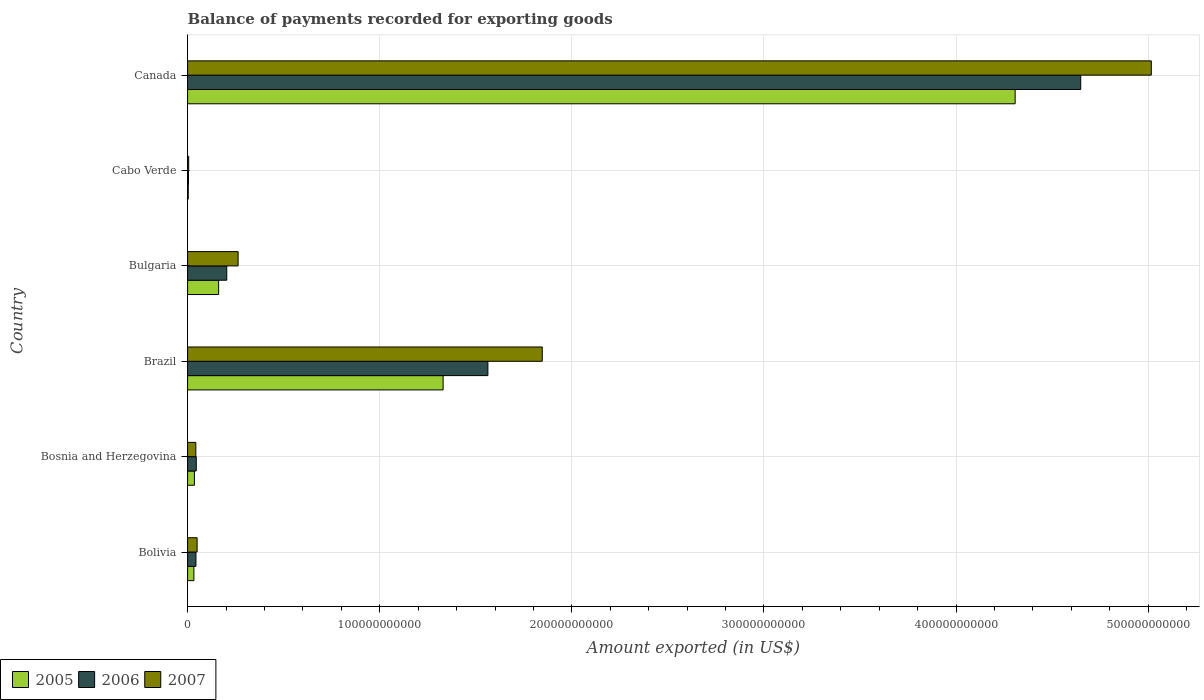How many different coloured bars are there?
Offer a terse response. 3. Are the number of bars on each tick of the Y-axis equal?
Make the answer very short. Yes. What is the label of the 5th group of bars from the top?
Provide a short and direct response. Bosnia and Herzegovina. In how many cases, is the number of bars for a given country not equal to the number of legend labels?
Give a very brief answer. 0. What is the amount exported in 2007 in Cabo Verde?
Your answer should be compact. 5.66e+08. Across all countries, what is the maximum amount exported in 2006?
Provide a succinct answer. 4.65e+11. Across all countries, what is the minimum amount exported in 2007?
Offer a terse response. 5.66e+08. In which country was the amount exported in 2005 maximum?
Your answer should be very brief. Canada. In which country was the amount exported in 2006 minimum?
Offer a very short reply. Cabo Verde. What is the total amount exported in 2006 in the graph?
Your answer should be very brief. 6.51e+11. What is the difference between the amount exported in 2005 in Bosnia and Herzegovina and that in Canada?
Provide a short and direct response. -4.27e+11. What is the difference between the amount exported in 2005 in Bolivia and the amount exported in 2007 in Bosnia and Herzegovina?
Your response must be concise. -1.01e+09. What is the average amount exported in 2007 per country?
Make the answer very short. 1.20e+11. What is the difference between the amount exported in 2007 and amount exported in 2005 in Cabo Verde?
Keep it short and to the point. 2.12e+08. In how many countries, is the amount exported in 2007 greater than 440000000000 US$?
Your answer should be compact. 1. What is the ratio of the amount exported in 2005 in Bosnia and Herzegovina to that in Bulgaria?
Provide a short and direct response. 0.22. What is the difference between the highest and the second highest amount exported in 2007?
Your answer should be very brief. 3.17e+11. What is the difference between the highest and the lowest amount exported in 2006?
Offer a terse response. 4.64e+11. How many bars are there?
Give a very brief answer. 18. Are all the bars in the graph horizontal?
Offer a very short reply. Yes. What is the difference between two consecutive major ticks on the X-axis?
Your answer should be very brief. 1.00e+11. Are the values on the major ticks of X-axis written in scientific E-notation?
Give a very brief answer. No. Does the graph contain any zero values?
Keep it short and to the point. No. Does the graph contain grids?
Ensure brevity in your answer.  Yes. Where does the legend appear in the graph?
Your response must be concise. Bottom left. What is the title of the graph?
Make the answer very short. Balance of payments recorded for exporting goods. Does "1981" appear as one of the legend labels in the graph?
Your answer should be compact. No. What is the label or title of the X-axis?
Keep it short and to the point. Amount exported (in US$). What is the Amount exported (in US$) in 2005 in Bolivia?
Your response must be concise. 3.28e+09. What is the Amount exported (in US$) in 2006 in Bolivia?
Offer a very short reply. 4.35e+09. What is the Amount exported (in US$) in 2007 in Bolivia?
Your response must be concise. 4.95e+09. What is the Amount exported (in US$) of 2005 in Bosnia and Herzegovina?
Provide a short and direct response. 3.54e+09. What is the Amount exported (in US$) in 2006 in Bosnia and Herzegovina?
Your answer should be very brief. 4.52e+09. What is the Amount exported (in US$) of 2007 in Bosnia and Herzegovina?
Give a very brief answer. 4.29e+09. What is the Amount exported (in US$) of 2005 in Brazil?
Provide a succinct answer. 1.33e+11. What is the Amount exported (in US$) of 2006 in Brazil?
Offer a very short reply. 1.56e+11. What is the Amount exported (in US$) in 2007 in Brazil?
Keep it short and to the point. 1.85e+11. What is the Amount exported (in US$) of 2005 in Bulgaria?
Your answer should be very brief. 1.62e+1. What is the Amount exported (in US$) of 2006 in Bulgaria?
Your response must be concise. 2.04e+1. What is the Amount exported (in US$) in 2007 in Bulgaria?
Your answer should be very brief. 2.63e+1. What is the Amount exported (in US$) in 2005 in Cabo Verde?
Keep it short and to the point. 3.54e+08. What is the Amount exported (in US$) of 2006 in Cabo Verde?
Make the answer very short. 4.72e+08. What is the Amount exported (in US$) in 2007 in Cabo Verde?
Provide a short and direct response. 5.66e+08. What is the Amount exported (in US$) of 2005 in Canada?
Your answer should be compact. 4.31e+11. What is the Amount exported (in US$) of 2006 in Canada?
Keep it short and to the point. 4.65e+11. What is the Amount exported (in US$) in 2007 in Canada?
Offer a terse response. 5.02e+11. Across all countries, what is the maximum Amount exported (in US$) in 2005?
Keep it short and to the point. 4.31e+11. Across all countries, what is the maximum Amount exported (in US$) in 2006?
Your answer should be very brief. 4.65e+11. Across all countries, what is the maximum Amount exported (in US$) of 2007?
Your answer should be compact. 5.02e+11. Across all countries, what is the minimum Amount exported (in US$) in 2005?
Your response must be concise. 3.54e+08. Across all countries, what is the minimum Amount exported (in US$) of 2006?
Give a very brief answer. 4.72e+08. Across all countries, what is the minimum Amount exported (in US$) of 2007?
Your response must be concise. 5.66e+08. What is the total Amount exported (in US$) of 2005 in the graph?
Offer a very short reply. 5.87e+11. What is the total Amount exported (in US$) of 2006 in the graph?
Provide a succinct answer. 6.51e+11. What is the total Amount exported (in US$) in 2007 in the graph?
Give a very brief answer. 7.22e+11. What is the difference between the Amount exported (in US$) in 2005 in Bolivia and that in Bosnia and Herzegovina?
Your answer should be compact. -2.65e+08. What is the difference between the Amount exported (in US$) in 2006 in Bolivia and that in Bosnia and Herzegovina?
Your response must be concise. -1.72e+08. What is the difference between the Amount exported (in US$) in 2007 in Bolivia and that in Bosnia and Herzegovina?
Your answer should be compact. 6.67e+08. What is the difference between the Amount exported (in US$) in 2005 in Bolivia and that in Brazil?
Provide a succinct answer. -1.30e+11. What is the difference between the Amount exported (in US$) of 2006 in Bolivia and that in Brazil?
Your answer should be compact. -1.52e+11. What is the difference between the Amount exported (in US$) of 2007 in Bolivia and that in Brazil?
Give a very brief answer. -1.80e+11. What is the difference between the Amount exported (in US$) in 2005 in Bolivia and that in Bulgaria?
Offer a terse response. -1.29e+1. What is the difference between the Amount exported (in US$) in 2006 in Bolivia and that in Bulgaria?
Offer a terse response. -1.60e+1. What is the difference between the Amount exported (in US$) of 2007 in Bolivia and that in Bulgaria?
Your answer should be compact. -2.13e+1. What is the difference between the Amount exported (in US$) of 2005 in Bolivia and that in Cabo Verde?
Your response must be concise. 2.93e+09. What is the difference between the Amount exported (in US$) in 2006 in Bolivia and that in Cabo Verde?
Give a very brief answer. 3.88e+09. What is the difference between the Amount exported (in US$) of 2007 in Bolivia and that in Cabo Verde?
Offer a terse response. 4.39e+09. What is the difference between the Amount exported (in US$) in 2005 in Bolivia and that in Canada?
Keep it short and to the point. -4.27e+11. What is the difference between the Amount exported (in US$) in 2006 in Bolivia and that in Canada?
Give a very brief answer. -4.61e+11. What is the difference between the Amount exported (in US$) of 2007 in Bolivia and that in Canada?
Offer a very short reply. -4.97e+11. What is the difference between the Amount exported (in US$) of 2005 in Bosnia and Herzegovina and that in Brazil?
Offer a very short reply. -1.29e+11. What is the difference between the Amount exported (in US$) of 2006 in Bosnia and Herzegovina and that in Brazil?
Your response must be concise. -1.52e+11. What is the difference between the Amount exported (in US$) in 2007 in Bosnia and Herzegovina and that in Brazil?
Give a very brief answer. -1.80e+11. What is the difference between the Amount exported (in US$) in 2005 in Bosnia and Herzegovina and that in Bulgaria?
Offer a very short reply. -1.26e+1. What is the difference between the Amount exported (in US$) of 2006 in Bosnia and Herzegovina and that in Bulgaria?
Give a very brief answer. -1.59e+1. What is the difference between the Amount exported (in US$) in 2007 in Bosnia and Herzegovina and that in Bulgaria?
Your response must be concise. -2.20e+1. What is the difference between the Amount exported (in US$) of 2005 in Bosnia and Herzegovina and that in Cabo Verde?
Your answer should be compact. 3.19e+09. What is the difference between the Amount exported (in US$) in 2006 in Bosnia and Herzegovina and that in Cabo Verde?
Provide a short and direct response. 4.05e+09. What is the difference between the Amount exported (in US$) of 2007 in Bosnia and Herzegovina and that in Cabo Verde?
Your answer should be compact. 3.72e+09. What is the difference between the Amount exported (in US$) in 2005 in Bosnia and Herzegovina and that in Canada?
Offer a very short reply. -4.27e+11. What is the difference between the Amount exported (in US$) in 2006 in Bosnia and Herzegovina and that in Canada?
Provide a short and direct response. -4.60e+11. What is the difference between the Amount exported (in US$) of 2007 in Bosnia and Herzegovina and that in Canada?
Your answer should be compact. -4.97e+11. What is the difference between the Amount exported (in US$) in 2005 in Brazil and that in Bulgaria?
Give a very brief answer. 1.17e+11. What is the difference between the Amount exported (in US$) in 2006 in Brazil and that in Bulgaria?
Your answer should be compact. 1.36e+11. What is the difference between the Amount exported (in US$) of 2007 in Brazil and that in Bulgaria?
Give a very brief answer. 1.58e+11. What is the difference between the Amount exported (in US$) of 2005 in Brazil and that in Cabo Verde?
Offer a terse response. 1.33e+11. What is the difference between the Amount exported (in US$) of 2006 in Brazil and that in Cabo Verde?
Your answer should be very brief. 1.56e+11. What is the difference between the Amount exported (in US$) of 2007 in Brazil and that in Cabo Verde?
Offer a terse response. 1.84e+11. What is the difference between the Amount exported (in US$) of 2005 in Brazil and that in Canada?
Your answer should be compact. -2.98e+11. What is the difference between the Amount exported (in US$) of 2006 in Brazil and that in Canada?
Provide a succinct answer. -3.09e+11. What is the difference between the Amount exported (in US$) in 2007 in Brazil and that in Canada?
Provide a succinct answer. -3.17e+11. What is the difference between the Amount exported (in US$) of 2005 in Bulgaria and that in Cabo Verde?
Keep it short and to the point. 1.58e+1. What is the difference between the Amount exported (in US$) of 2006 in Bulgaria and that in Cabo Verde?
Ensure brevity in your answer.  1.99e+1. What is the difference between the Amount exported (in US$) of 2007 in Bulgaria and that in Cabo Verde?
Give a very brief answer. 2.57e+1. What is the difference between the Amount exported (in US$) of 2005 in Bulgaria and that in Canada?
Your response must be concise. -4.15e+11. What is the difference between the Amount exported (in US$) of 2006 in Bulgaria and that in Canada?
Provide a succinct answer. -4.44e+11. What is the difference between the Amount exported (in US$) in 2007 in Bulgaria and that in Canada?
Give a very brief answer. -4.75e+11. What is the difference between the Amount exported (in US$) in 2005 in Cabo Verde and that in Canada?
Offer a very short reply. -4.30e+11. What is the difference between the Amount exported (in US$) in 2006 in Cabo Verde and that in Canada?
Make the answer very short. -4.64e+11. What is the difference between the Amount exported (in US$) of 2007 in Cabo Verde and that in Canada?
Offer a very short reply. -5.01e+11. What is the difference between the Amount exported (in US$) of 2005 in Bolivia and the Amount exported (in US$) of 2006 in Bosnia and Herzegovina?
Your response must be concise. -1.24e+09. What is the difference between the Amount exported (in US$) in 2005 in Bolivia and the Amount exported (in US$) in 2007 in Bosnia and Herzegovina?
Ensure brevity in your answer.  -1.01e+09. What is the difference between the Amount exported (in US$) in 2006 in Bolivia and the Amount exported (in US$) in 2007 in Bosnia and Herzegovina?
Provide a short and direct response. 6.18e+07. What is the difference between the Amount exported (in US$) in 2005 in Bolivia and the Amount exported (in US$) in 2006 in Brazil?
Your answer should be compact. -1.53e+11. What is the difference between the Amount exported (in US$) in 2005 in Bolivia and the Amount exported (in US$) in 2007 in Brazil?
Give a very brief answer. -1.81e+11. What is the difference between the Amount exported (in US$) of 2006 in Bolivia and the Amount exported (in US$) of 2007 in Brazil?
Provide a short and direct response. -1.80e+11. What is the difference between the Amount exported (in US$) in 2005 in Bolivia and the Amount exported (in US$) in 2006 in Bulgaria?
Offer a very short reply. -1.71e+1. What is the difference between the Amount exported (in US$) in 2005 in Bolivia and the Amount exported (in US$) in 2007 in Bulgaria?
Ensure brevity in your answer.  -2.30e+1. What is the difference between the Amount exported (in US$) of 2006 in Bolivia and the Amount exported (in US$) of 2007 in Bulgaria?
Your answer should be very brief. -2.19e+1. What is the difference between the Amount exported (in US$) in 2005 in Bolivia and the Amount exported (in US$) in 2006 in Cabo Verde?
Offer a very short reply. 2.81e+09. What is the difference between the Amount exported (in US$) in 2005 in Bolivia and the Amount exported (in US$) in 2007 in Cabo Verde?
Offer a very short reply. 2.71e+09. What is the difference between the Amount exported (in US$) of 2006 in Bolivia and the Amount exported (in US$) of 2007 in Cabo Verde?
Provide a succinct answer. 3.78e+09. What is the difference between the Amount exported (in US$) in 2005 in Bolivia and the Amount exported (in US$) in 2006 in Canada?
Provide a succinct answer. -4.62e+11. What is the difference between the Amount exported (in US$) of 2005 in Bolivia and the Amount exported (in US$) of 2007 in Canada?
Provide a succinct answer. -4.98e+11. What is the difference between the Amount exported (in US$) of 2006 in Bolivia and the Amount exported (in US$) of 2007 in Canada?
Your answer should be very brief. -4.97e+11. What is the difference between the Amount exported (in US$) of 2005 in Bosnia and Herzegovina and the Amount exported (in US$) of 2006 in Brazil?
Give a very brief answer. -1.53e+11. What is the difference between the Amount exported (in US$) of 2005 in Bosnia and Herzegovina and the Amount exported (in US$) of 2007 in Brazil?
Keep it short and to the point. -1.81e+11. What is the difference between the Amount exported (in US$) of 2006 in Bosnia and Herzegovina and the Amount exported (in US$) of 2007 in Brazil?
Offer a terse response. -1.80e+11. What is the difference between the Amount exported (in US$) of 2005 in Bosnia and Herzegovina and the Amount exported (in US$) of 2006 in Bulgaria?
Keep it short and to the point. -1.68e+1. What is the difference between the Amount exported (in US$) of 2005 in Bosnia and Herzegovina and the Amount exported (in US$) of 2007 in Bulgaria?
Ensure brevity in your answer.  -2.28e+1. What is the difference between the Amount exported (in US$) in 2006 in Bosnia and Herzegovina and the Amount exported (in US$) in 2007 in Bulgaria?
Keep it short and to the point. -2.18e+1. What is the difference between the Amount exported (in US$) in 2005 in Bosnia and Herzegovina and the Amount exported (in US$) in 2006 in Cabo Verde?
Your response must be concise. 3.07e+09. What is the difference between the Amount exported (in US$) of 2005 in Bosnia and Herzegovina and the Amount exported (in US$) of 2007 in Cabo Verde?
Offer a terse response. 2.98e+09. What is the difference between the Amount exported (in US$) of 2006 in Bosnia and Herzegovina and the Amount exported (in US$) of 2007 in Cabo Verde?
Offer a terse response. 3.96e+09. What is the difference between the Amount exported (in US$) in 2005 in Bosnia and Herzegovina and the Amount exported (in US$) in 2006 in Canada?
Your response must be concise. -4.61e+11. What is the difference between the Amount exported (in US$) in 2005 in Bosnia and Herzegovina and the Amount exported (in US$) in 2007 in Canada?
Your response must be concise. -4.98e+11. What is the difference between the Amount exported (in US$) of 2006 in Bosnia and Herzegovina and the Amount exported (in US$) of 2007 in Canada?
Provide a succinct answer. -4.97e+11. What is the difference between the Amount exported (in US$) in 2005 in Brazil and the Amount exported (in US$) in 2006 in Bulgaria?
Provide a succinct answer. 1.13e+11. What is the difference between the Amount exported (in US$) of 2005 in Brazil and the Amount exported (in US$) of 2007 in Bulgaria?
Provide a succinct answer. 1.07e+11. What is the difference between the Amount exported (in US$) in 2006 in Brazil and the Amount exported (in US$) in 2007 in Bulgaria?
Ensure brevity in your answer.  1.30e+11. What is the difference between the Amount exported (in US$) of 2005 in Brazil and the Amount exported (in US$) of 2006 in Cabo Verde?
Offer a very short reply. 1.33e+11. What is the difference between the Amount exported (in US$) in 2005 in Brazil and the Amount exported (in US$) in 2007 in Cabo Verde?
Your answer should be compact. 1.32e+11. What is the difference between the Amount exported (in US$) in 2006 in Brazil and the Amount exported (in US$) in 2007 in Cabo Verde?
Your answer should be very brief. 1.56e+11. What is the difference between the Amount exported (in US$) of 2005 in Brazil and the Amount exported (in US$) of 2006 in Canada?
Provide a succinct answer. -3.32e+11. What is the difference between the Amount exported (in US$) in 2005 in Brazil and the Amount exported (in US$) in 2007 in Canada?
Your response must be concise. -3.69e+11. What is the difference between the Amount exported (in US$) of 2006 in Brazil and the Amount exported (in US$) of 2007 in Canada?
Make the answer very short. -3.45e+11. What is the difference between the Amount exported (in US$) of 2005 in Bulgaria and the Amount exported (in US$) of 2006 in Cabo Verde?
Make the answer very short. 1.57e+1. What is the difference between the Amount exported (in US$) in 2005 in Bulgaria and the Amount exported (in US$) in 2007 in Cabo Verde?
Make the answer very short. 1.56e+1. What is the difference between the Amount exported (in US$) in 2006 in Bulgaria and the Amount exported (in US$) in 2007 in Cabo Verde?
Provide a short and direct response. 1.98e+1. What is the difference between the Amount exported (in US$) in 2005 in Bulgaria and the Amount exported (in US$) in 2006 in Canada?
Your response must be concise. -4.49e+11. What is the difference between the Amount exported (in US$) of 2005 in Bulgaria and the Amount exported (in US$) of 2007 in Canada?
Make the answer very short. -4.85e+11. What is the difference between the Amount exported (in US$) of 2006 in Bulgaria and the Amount exported (in US$) of 2007 in Canada?
Ensure brevity in your answer.  -4.81e+11. What is the difference between the Amount exported (in US$) of 2005 in Cabo Verde and the Amount exported (in US$) of 2006 in Canada?
Give a very brief answer. -4.65e+11. What is the difference between the Amount exported (in US$) in 2005 in Cabo Verde and the Amount exported (in US$) in 2007 in Canada?
Your answer should be compact. -5.01e+11. What is the difference between the Amount exported (in US$) of 2006 in Cabo Verde and the Amount exported (in US$) of 2007 in Canada?
Make the answer very short. -5.01e+11. What is the average Amount exported (in US$) in 2005 per country?
Your answer should be compact. 9.78e+1. What is the average Amount exported (in US$) in 2006 per country?
Ensure brevity in your answer.  1.08e+11. What is the average Amount exported (in US$) of 2007 per country?
Keep it short and to the point. 1.20e+11. What is the difference between the Amount exported (in US$) of 2005 and Amount exported (in US$) of 2006 in Bolivia?
Your answer should be compact. -1.07e+09. What is the difference between the Amount exported (in US$) in 2005 and Amount exported (in US$) in 2007 in Bolivia?
Offer a very short reply. -1.68e+09. What is the difference between the Amount exported (in US$) in 2006 and Amount exported (in US$) in 2007 in Bolivia?
Your answer should be very brief. -6.05e+08. What is the difference between the Amount exported (in US$) in 2005 and Amount exported (in US$) in 2006 in Bosnia and Herzegovina?
Keep it short and to the point. -9.77e+08. What is the difference between the Amount exported (in US$) of 2005 and Amount exported (in US$) of 2007 in Bosnia and Herzegovina?
Ensure brevity in your answer.  -7.43e+08. What is the difference between the Amount exported (in US$) of 2006 and Amount exported (in US$) of 2007 in Bosnia and Herzegovina?
Provide a short and direct response. 2.34e+08. What is the difference between the Amount exported (in US$) in 2005 and Amount exported (in US$) in 2006 in Brazil?
Your answer should be very brief. -2.33e+1. What is the difference between the Amount exported (in US$) of 2005 and Amount exported (in US$) of 2007 in Brazil?
Offer a terse response. -5.16e+1. What is the difference between the Amount exported (in US$) of 2006 and Amount exported (in US$) of 2007 in Brazil?
Offer a very short reply. -2.83e+1. What is the difference between the Amount exported (in US$) of 2005 and Amount exported (in US$) of 2006 in Bulgaria?
Provide a succinct answer. -4.23e+09. What is the difference between the Amount exported (in US$) in 2005 and Amount exported (in US$) in 2007 in Bulgaria?
Provide a short and direct response. -1.01e+1. What is the difference between the Amount exported (in US$) of 2006 and Amount exported (in US$) of 2007 in Bulgaria?
Give a very brief answer. -5.91e+09. What is the difference between the Amount exported (in US$) of 2005 and Amount exported (in US$) of 2006 in Cabo Verde?
Make the answer very short. -1.19e+08. What is the difference between the Amount exported (in US$) of 2005 and Amount exported (in US$) of 2007 in Cabo Verde?
Offer a terse response. -2.12e+08. What is the difference between the Amount exported (in US$) of 2006 and Amount exported (in US$) of 2007 in Cabo Verde?
Keep it short and to the point. -9.37e+07. What is the difference between the Amount exported (in US$) in 2005 and Amount exported (in US$) in 2006 in Canada?
Provide a short and direct response. -3.41e+1. What is the difference between the Amount exported (in US$) of 2005 and Amount exported (in US$) of 2007 in Canada?
Give a very brief answer. -7.09e+1. What is the difference between the Amount exported (in US$) of 2006 and Amount exported (in US$) of 2007 in Canada?
Provide a succinct answer. -3.67e+1. What is the ratio of the Amount exported (in US$) in 2005 in Bolivia to that in Bosnia and Herzegovina?
Provide a short and direct response. 0.93. What is the ratio of the Amount exported (in US$) of 2007 in Bolivia to that in Bosnia and Herzegovina?
Provide a short and direct response. 1.16. What is the ratio of the Amount exported (in US$) in 2005 in Bolivia to that in Brazil?
Your answer should be compact. 0.02. What is the ratio of the Amount exported (in US$) of 2006 in Bolivia to that in Brazil?
Your answer should be very brief. 0.03. What is the ratio of the Amount exported (in US$) in 2007 in Bolivia to that in Brazil?
Offer a very short reply. 0.03. What is the ratio of the Amount exported (in US$) in 2005 in Bolivia to that in Bulgaria?
Provide a short and direct response. 0.2. What is the ratio of the Amount exported (in US$) of 2006 in Bolivia to that in Bulgaria?
Offer a very short reply. 0.21. What is the ratio of the Amount exported (in US$) of 2007 in Bolivia to that in Bulgaria?
Ensure brevity in your answer.  0.19. What is the ratio of the Amount exported (in US$) in 2005 in Bolivia to that in Cabo Verde?
Give a very brief answer. 9.27. What is the ratio of the Amount exported (in US$) in 2006 in Bolivia to that in Cabo Verde?
Keep it short and to the point. 9.21. What is the ratio of the Amount exported (in US$) of 2007 in Bolivia to that in Cabo Verde?
Give a very brief answer. 8.75. What is the ratio of the Amount exported (in US$) of 2005 in Bolivia to that in Canada?
Provide a short and direct response. 0.01. What is the ratio of the Amount exported (in US$) in 2006 in Bolivia to that in Canada?
Offer a very short reply. 0.01. What is the ratio of the Amount exported (in US$) of 2007 in Bolivia to that in Canada?
Provide a short and direct response. 0.01. What is the ratio of the Amount exported (in US$) of 2005 in Bosnia and Herzegovina to that in Brazil?
Offer a terse response. 0.03. What is the ratio of the Amount exported (in US$) in 2006 in Bosnia and Herzegovina to that in Brazil?
Provide a succinct answer. 0.03. What is the ratio of the Amount exported (in US$) of 2007 in Bosnia and Herzegovina to that in Brazil?
Offer a terse response. 0.02. What is the ratio of the Amount exported (in US$) of 2005 in Bosnia and Herzegovina to that in Bulgaria?
Keep it short and to the point. 0.22. What is the ratio of the Amount exported (in US$) in 2006 in Bosnia and Herzegovina to that in Bulgaria?
Ensure brevity in your answer.  0.22. What is the ratio of the Amount exported (in US$) in 2007 in Bosnia and Herzegovina to that in Bulgaria?
Your answer should be compact. 0.16. What is the ratio of the Amount exported (in US$) of 2005 in Bosnia and Herzegovina to that in Cabo Verde?
Give a very brief answer. 10.02. What is the ratio of the Amount exported (in US$) in 2006 in Bosnia and Herzegovina to that in Cabo Verde?
Provide a short and direct response. 9.57. What is the ratio of the Amount exported (in US$) of 2007 in Bosnia and Herzegovina to that in Cabo Verde?
Provide a short and direct response. 7.57. What is the ratio of the Amount exported (in US$) in 2005 in Bosnia and Herzegovina to that in Canada?
Give a very brief answer. 0.01. What is the ratio of the Amount exported (in US$) of 2006 in Bosnia and Herzegovina to that in Canada?
Offer a very short reply. 0.01. What is the ratio of the Amount exported (in US$) of 2007 in Bosnia and Herzegovina to that in Canada?
Give a very brief answer. 0.01. What is the ratio of the Amount exported (in US$) of 2005 in Brazil to that in Bulgaria?
Make the answer very short. 8.23. What is the ratio of the Amount exported (in US$) of 2006 in Brazil to that in Bulgaria?
Offer a terse response. 7.67. What is the ratio of the Amount exported (in US$) in 2007 in Brazil to that in Bulgaria?
Provide a succinct answer. 7.02. What is the ratio of the Amount exported (in US$) in 2005 in Brazil to that in Cabo Verde?
Provide a short and direct response. 375.95. What is the ratio of the Amount exported (in US$) of 2006 in Brazil to that in Cabo Verde?
Give a very brief answer. 330.94. What is the ratio of the Amount exported (in US$) of 2007 in Brazil to that in Cabo Verde?
Keep it short and to the point. 326.14. What is the ratio of the Amount exported (in US$) in 2005 in Brazil to that in Canada?
Provide a short and direct response. 0.31. What is the ratio of the Amount exported (in US$) of 2006 in Brazil to that in Canada?
Ensure brevity in your answer.  0.34. What is the ratio of the Amount exported (in US$) in 2007 in Brazil to that in Canada?
Your answer should be very brief. 0.37. What is the ratio of the Amount exported (in US$) of 2005 in Bulgaria to that in Cabo Verde?
Make the answer very short. 45.67. What is the ratio of the Amount exported (in US$) of 2006 in Bulgaria to that in Cabo Verde?
Ensure brevity in your answer.  43.17. What is the ratio of the Amount exported (in US$) of 2007 in Bulgaria to that in Cabo Verde?
Make the answer very short. 46.46. What is the ratio of the Amount exported (in US$) in 2005 in Bulgaria to that in Canada?
Your answer should be very brief. 0.04. What is the ratio of the Amount exported (in US$) in 2006 in Bulgaria to that in Canada?
Your answer should be very brief. 0.04. What is the ratio of the Amount exported (in US$) in 2007 in Bulgaria to that in Canada?
Provide a short and direct response. 0.05. What is the ratio of the Amount exported (in US$) in 2005 in Cabo Verde to that in Canada?
Ensure brevity in your answer.  0. What is the ratio of the Amount exported (in US$) in 2006 in Cabo Verde to that in Canada?
Provide a short and direct response. 0. What is the ratio of the Amount exported (in US$) of 2007 in Cabo Verde to that in Canada?
Offer a very short reply. 0. What is the difference between the highest and the second highest Amount exported (in US$) of 2005?
Ensure brevity in your answer.  2.98e+11. What is the difference between the highest and the second highest Amount exported (in US$) in 2006?
Provide a succinct answer. 3.09e+11. What is the difference between the highest and the second highest Amount exported (in US$) of 2007?
Your answer should be very brief. 3.17e+11. What is the difference between the highest and the lowest Amount exported (in US$) in 2005?
Offer a terse response. 4.30e+11. What is the difference between the highest and the lowest Amount exported (in US$) of 2006?
Provide a succinct answer. 4.64e+11. What is the difference between the highest and the lowest Amount exported (in US$) of 2007?
Ensure brevity in your answer.  5.01e+11. 